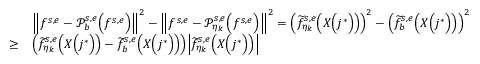Convert formula to latex. <formula><loc_0><loc_0><loc_500><loc_500>\begin{array} { r l } & { \left \| f ^ { s , e } - \mathcal { P } _ { b } ^ { s , e } \left ( f ^ { s , e } \right ) \right \| ^ { 2 } - \left \| f ^ { s , e } - \mathcal { P } _ { \eta _ { k } } ^ { s , e } \left ( f ^ { s , e } \right ) \right \| ^ { 2 } = \left ( \widetilde { f } _ { \eta _ { k } } ^ { s , e } \left ( X \left ( j ^ { * } \right ) \right ) \right ) ^ { 2 } - \left ( \widetilde { f } _ { b } ^ { s , e } \left ( X \left ( j ^ { * } \right ) \right ) \right ) ^ { 2 } } \\ { \geq } & { \left ( \widetilde { f } _ { \eta _ { k } } ^ { s , e } \left ( X \left ( j ^ { * } \right ) \right ) - \widetilde { f } _ { b } ^ { s , e } \left ( X \left ( j ^ { * } \right ) \right ) \right ) \left | \widetilde { f } _ { \eta _ { k } } ^ { s , e } \left ( X \left ( j ^ { * } \right ) \right ) \right | } \end{array}</formula> 